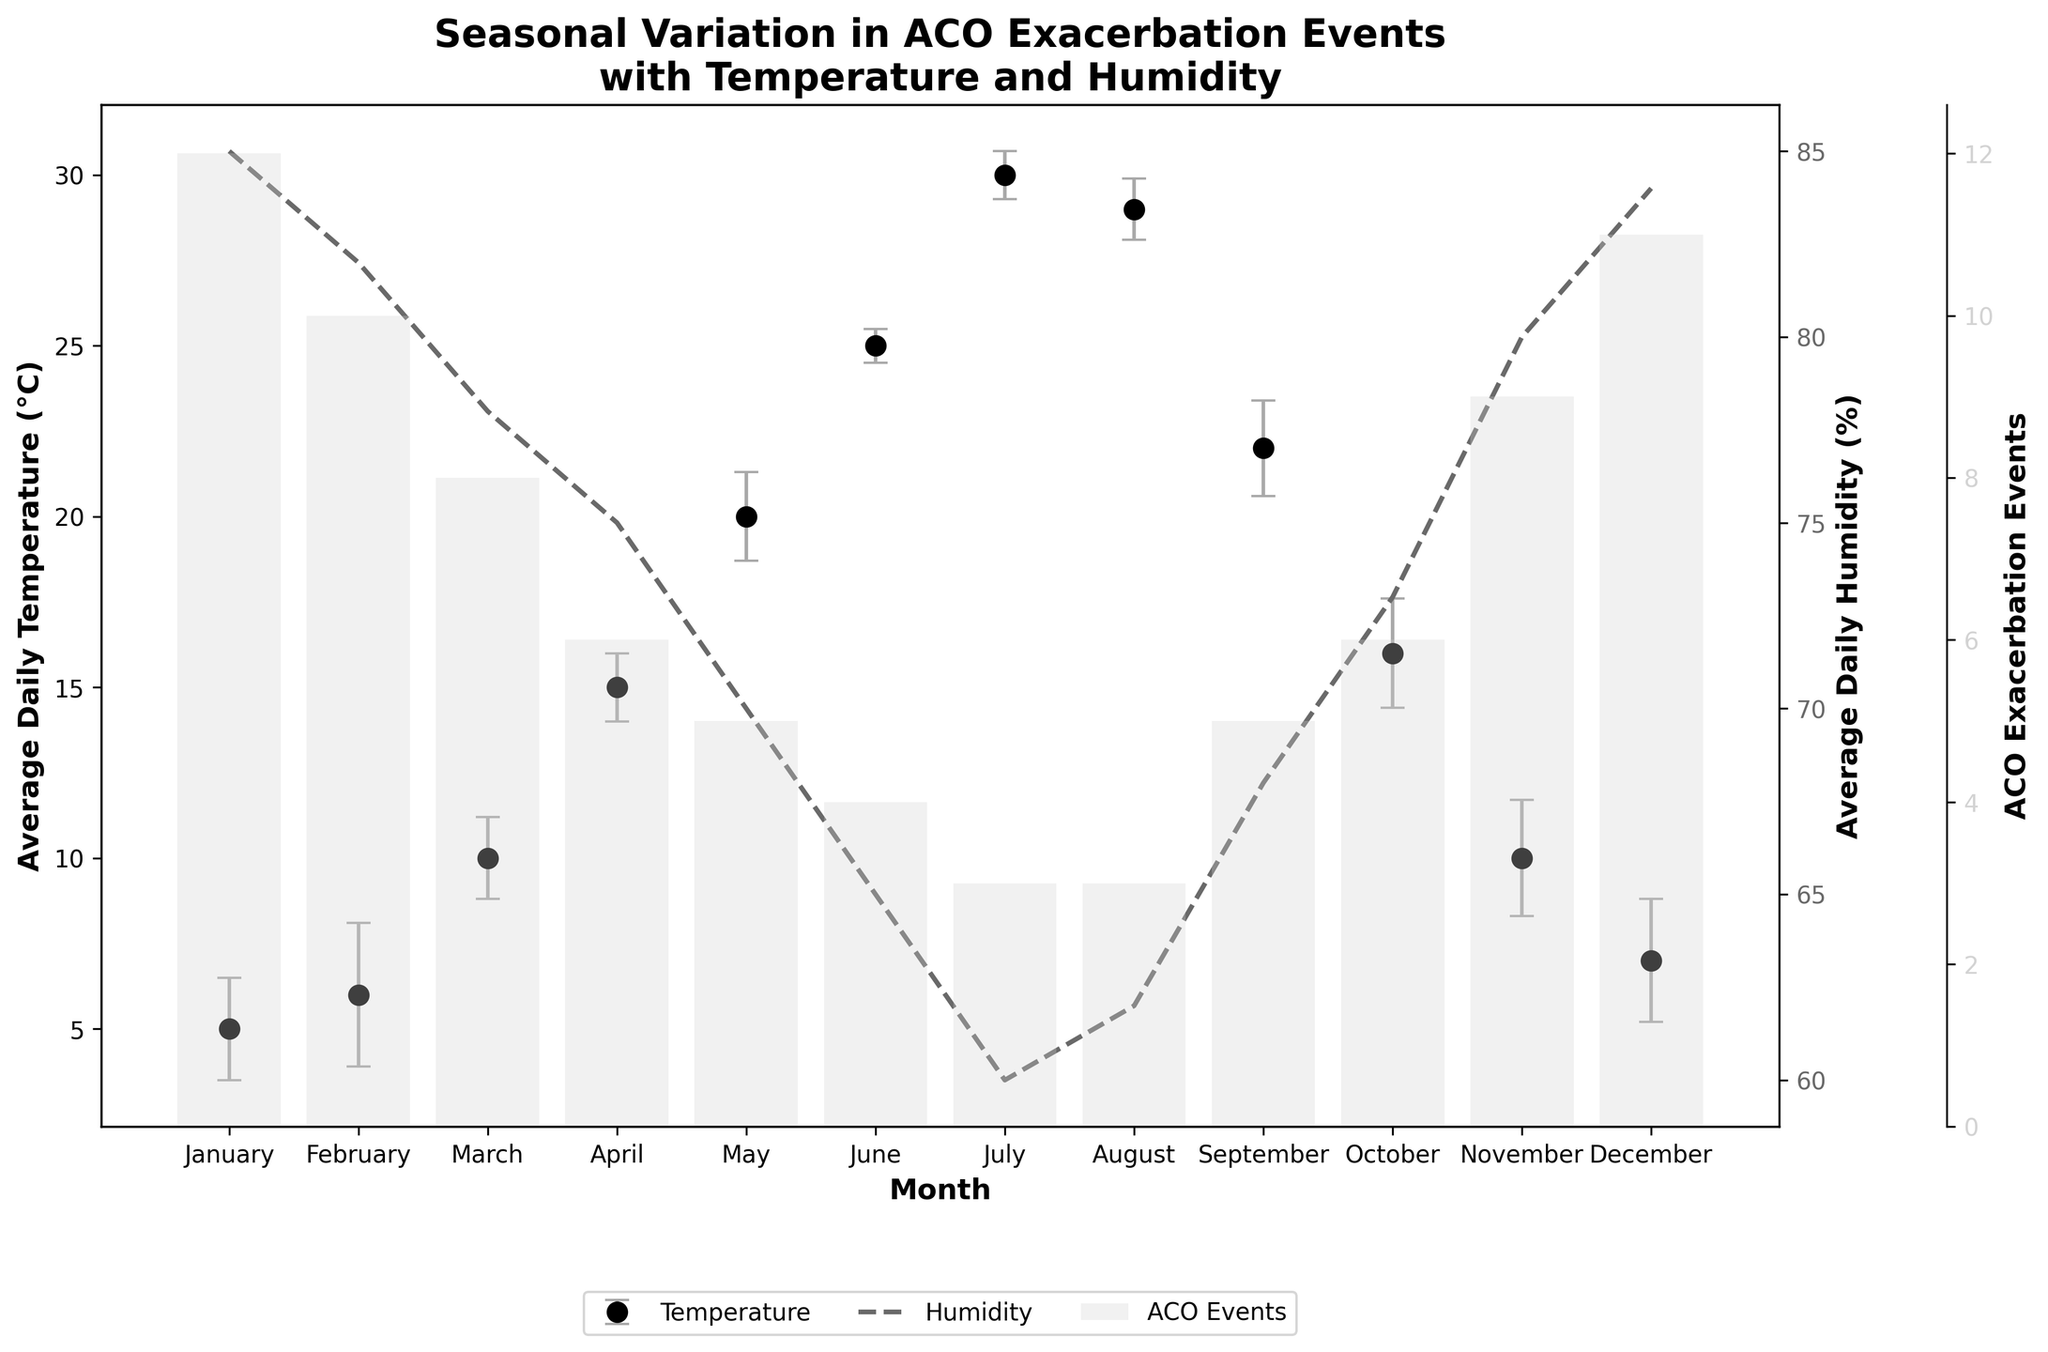What is the average daily temperature in April? Look at the Average Daily Temperature (°C) column in the figure for the month of April. The value shown is 15°C.
Answer: 15°C Which month has the highest number of ACO exacerbation events? To determine the month with the highest number of ACO exacerbation events, look at the tallest bar in the ACO Exacerbation Events series. In this case, January has the highest value with 12 events.
Answer: January How does the average daily humidity in July compare to that in January? Find the Average Daily Humidity (%) for both July and January. In July, the humidity is 60%, and in January, it is 85%. July's humidity is lower than January's by 25%.
Answer: July is 25% lower What is the range of the standard deviation of ACO exacerbation events throughout the year? Look at the Standard Deviation of Events column and identify the minimum and maximum values. The values range from 0.5 (June) to 2.1 (February). Subtract the smallest value from the largest value: 2.1 - 0.5 = 1.6.
Answer: 1.6 Which months have fewer than 5 ACO exacerbation events? Identify the months where the ACO Exacerbation Events bar is below 5. These months are June (4), July (3), and August (3).
Answer: June, July, August What is the average ACO exacerbation events in the months with an average daily temperature of 20°C or higher? Find the months with an Average Daily Temperature (°C) >= 20°C (May - 20°C, June - 25°C, July - 30°C, August - 29°C, September - 22°C). Sum the ACO Exacerbation Events for these months (5 + 4 + 3 + 3 + 5 = 20). Then divide by the number of these months, which is 5: 20/5 = 4.
Answer: 4 Which month shows a decrease in ACO exacerbation events compared to the previous month? Compare the bar heights in the ACO Exacerbation Events series from one month to the next. February has fewer events (10) compared to January (12), showing a decrease of 2 events.
Answer: February For which months do the error bars in ACO exacerbation events have the greatest and least range? The range is determined by the length of the error bars, corresponding to the standard deviation of events. The greatest range is in February (2.1), and the least is in June (0.5).
Answer: Greatest: February, Least: June Do ACO exacerbation events correlate more with average daily temperature or average daily humidity? To determine correlation, observe the trends in the lines for average daily temperature and humidity against the bars for ACO exacerbation events. It is observed that higher ACO events are in the months with lower temperatures and higher humidity. Therefore, higher ACO events correlate more with lower temperatures and higher humidity, especially in winter months.
Answer: Lower temperature and higher humidity 